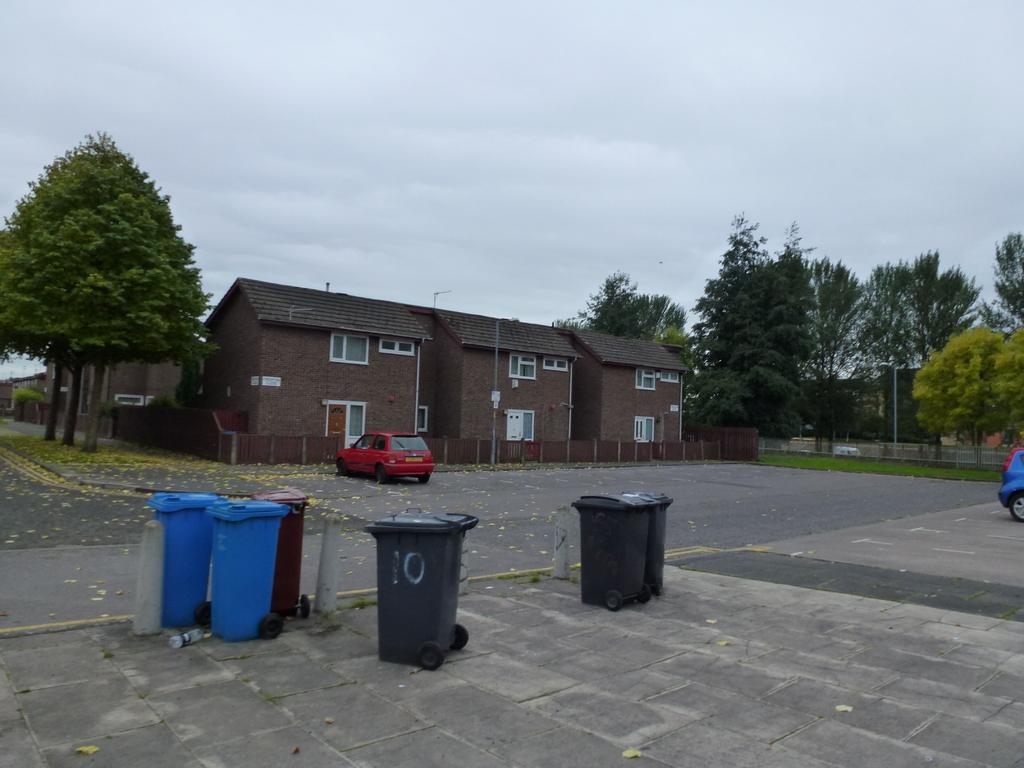Describe this image in one or two sentences. In this image we can see a house with roof, windows and a fence. We can also see some trees around the house. Car and dried leaves on the road, Dustbin with wheels and an empty bottle on the footpath, grass, fence, pole and the sky which looks cloudy. 